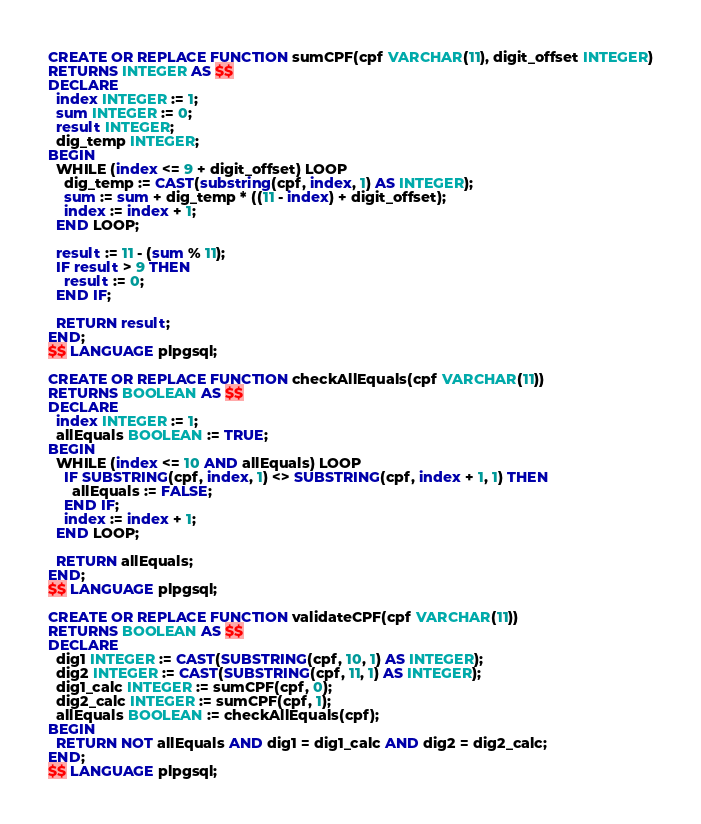<code> <loc_0><loc_0><loc_500><loc_500><_SQL_>CREATE OR REPLACE FUNCTION sumCPF(cpf VARCHAR(11), digit_offset INTEGER)
RETURNS INTEGER AS $$
DECLARE 
  index INTEGER := 1;
  sum INTEGER := 0;
  result INTEGER;
  dig_temp INTEGER;
BEGIN
  WHILE (index <= 9 + digit_offset) LOOP
    dig_temp := CAST(substring(cpf, index, 1) AS INTEGER);
    sum := sum + dig_temp * ((11 - index) + digit_offset);
    index := index + 1;
  END LOOP;

  result := 11 - (sum % 11);
  IF result > 9 THEN
    result := 0;
  END IF;

  RETURN result;
END;
$$ LANGUAGE plpgsql;

CREATE OR REPLACE FUNCTION checkAllEquals(cpf VARCHAR(11))
RETURNS BOOLEAN AS $$
DECLARE
  index INTEGER := 1;
  allEquals BOOLEAN := TRUE;
BEGIN
  WHILE (index <= 10 AND allEquals) LOOP
    IF SUBSTRING(cpf, index, 1) <> SUBSTRING(cpf, index + 1, 1) THEN
      allEquals := FALSE;
    END IF;
    index := index + 1;
  END LOOP;

  RETURN allEquals;
END;
$$ LANGUAGE plpgsql;

CREATE OR REPLACE FUNCTION validateCPF(cpf VARCHAR(11))
RETURNS BOOLEAN AS $$
DECLARE 
  dig1 INTEGER := CAST(SUBSTRING(cpf, 10, 1) AS INTEGER);
  dig2 INTEGER := CAST(SUBSTRING(cpf, 11, 1) AS INTEGER);
  dig1_calc INTEGER := sumCPF(cpf, 0);
  dig2_calc INTEGER := sumCPF(cpf, 1);
  allEquals BOOLEAN := checkAllEquals(cpf);
BEGIN
  RETURN NOT allEquals AND dig1 = dig1_calc AND dig2 = dig2_calc;
END;
$$ LANGUAGE plpgsql;</code> 